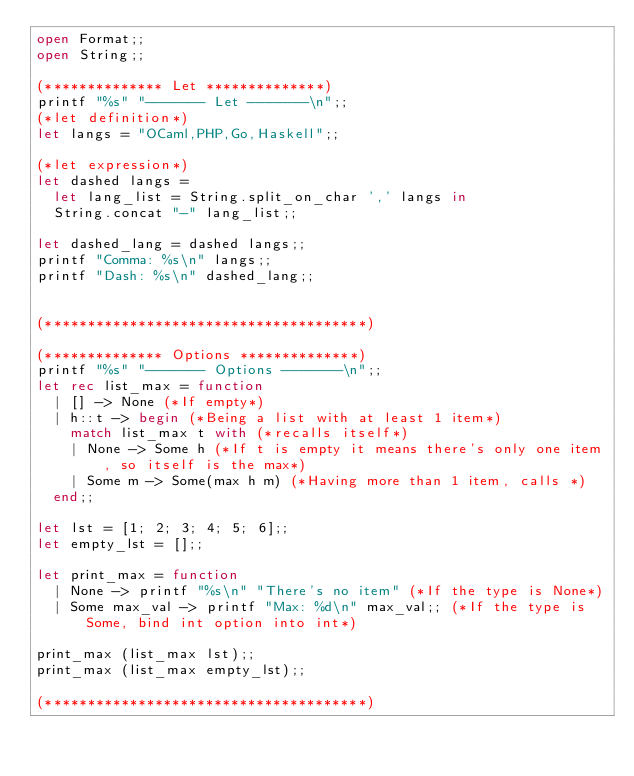<code> <loc_0><loc_0><loc_500><loc_500><_OCaml_>open Format;;
open String;;

(************** Let **************)
printf "%s" "------- Let -------\n";;
(*let definition*)
let langs = "OCaml,PHP,Go,Haskell";;

(*let expression*)
let dashed langs =
  let lang_list = String.split_on_char ',' langs in
  String.concat "-" lang_list;;

let dashed_lang = dashed langs;;
printf "Comma: %s\n" langs;;
printf "Dash: %s\n" dashed_lang;;


(**************************************)

(************** Options **************)
printf "%s" "------- Options -------\n";;
let rec list_max = function
  | [] -> None (*If empty*)
  | h::t -> begin (*Being a list with at least 1 item*)
    match list_max t with (*recalls itself*)
    | None -> Some h (*If t is empty it means there's only one item, so itself is the max*)
    | Some m -> Some(max h m) (*Having more than 1 item, calls *)
  end;;

let lst = [1; 2; 3; 4; 5; 6];;
let empty_lst = [];;

let print_max = function
  | None -> printf "%s\n" "There's no item" (*If the type is None*)
  | Some max_val -> printf "Max: %d\n" max_val;; (*If the type is Some, bind int option into int*)

print_max (list_max lst);;
print_max (list_max empty_lst);;

(**************************************)
</code> 